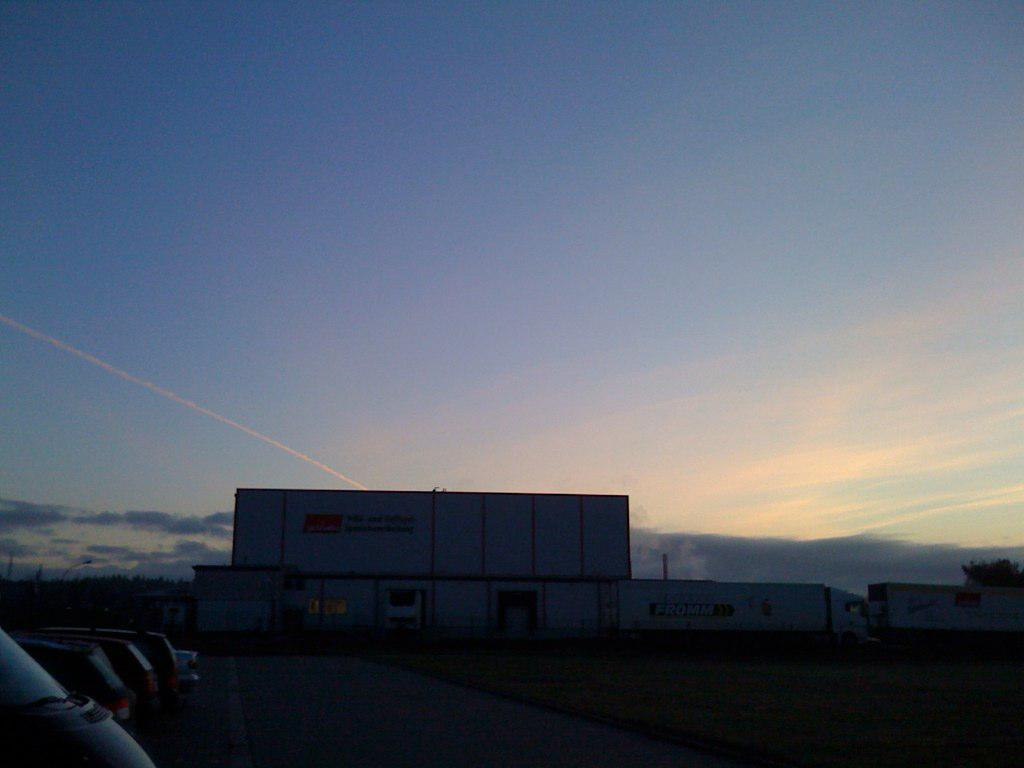What type of vehicles are on the left side of the image? There are cars on the left side of the image. What structure is located in the middle of the image? There is a building in the middle of the image. What type of vehicles are on the right side of the image? There are trucks on the right side of the image. What is visible at the top of the image? The sky is visible at the top of the image. Can you tell me how many beetles are crawling on the building in the image? There are no beetles present in the image; it features cars, a building, and trucks. What type of process is being carried out by the fireman in the image? There is no fireman present in the image. 